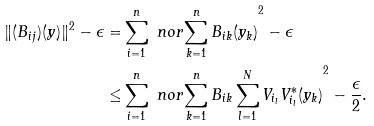Convert formula to latex. <formula><loc_0><loc_0><loc_500><loc_500>\| ( B _ { i j } ) ( y ) \| ^ { 2 } - \epsilon = & \sum _ { i = 1 } ^ { n } \ n o r { \sum _ { k = 1 } ^ { n } B _ { i k } ( y _ { k } ) } ^ { 2 } - \epsilon \\ \leq & \sum _ { i = 1 } ^ { n } \ n o r { \sum _ { k = 1 } ^ { n } B _ { i k } \sum _ { l = 1 } ^ { N } V _ { i _ { l } } V _ { i _ { l } } ^ { * } ( y _ { k } ) } ^ { 2 } - \frac { \epsilon } { 2 } .</formula> 